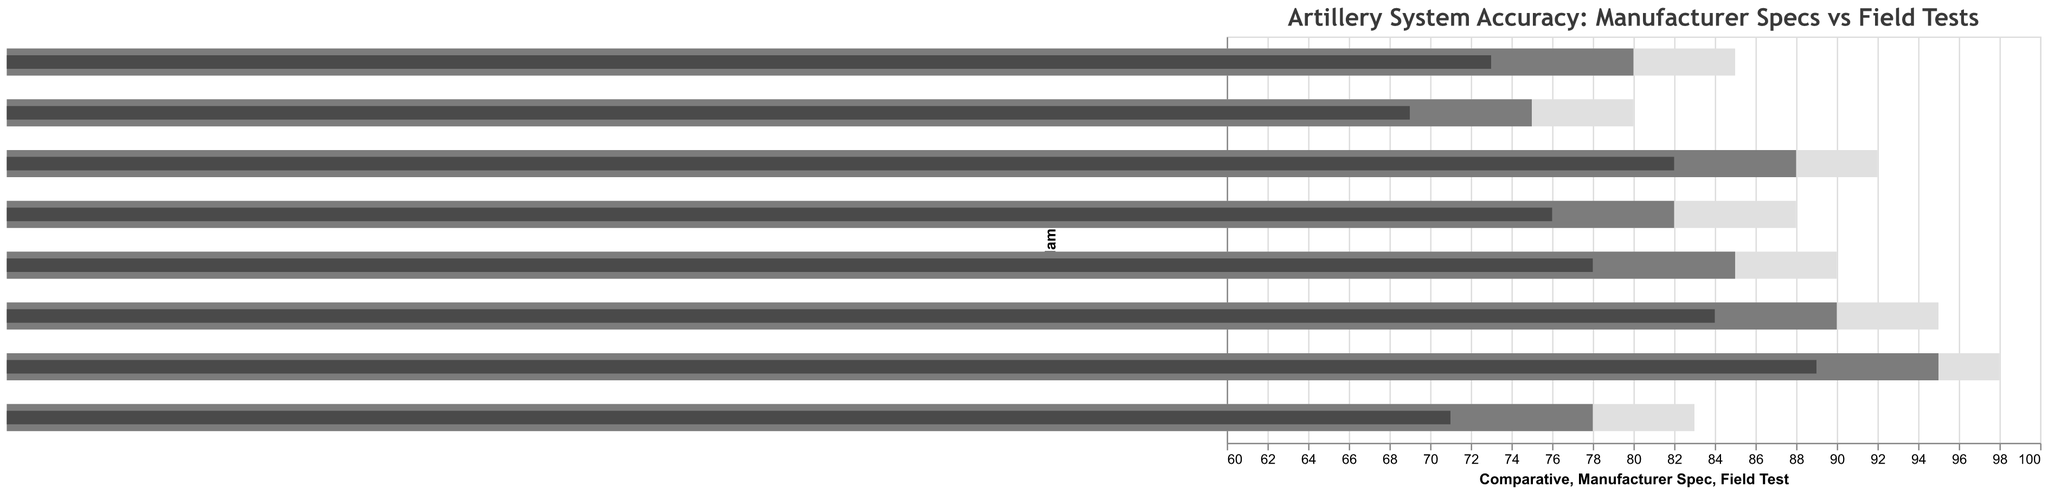Which artillery system has the highest value in the Manufacturer Spec column? Sort the values in the Manufacturer Spec column and identify the highest one. The Panzerhaubitze 2000 has the highest value at 95.
Answer: Panzerhaubitze 2000 How much lower is the Field Test accuracy of the Type 99 155mm compared to its Manufacturer Spec? Subtract the Field Test value from the Manufacturer Spec value for the Type 99 155mm. The difference is 78 - 71 = 7.
Answer: 7 Which artillery system has the closest Field Test accuracy to its Manufacturer Spec? Calculate the differences between each Manufacturer Spec and its corresponding Field Test accuracy. The M777 155mm has a difference of 6, which is the smallest.
Answer: M777 155mm What is the average Field Test accuracy across all artillery systems? Add up all the Field Test accuracies and divide by the number of systems. (78 + 84 + 89 + 73 + 69 + 82 + 76 + 71) / 8 = 622 / 8 = 77.75.
Answer: 77.75 Which artillery system has the lowest Comparative accuracy? Sort the values in the Comparative column and identify the lowest one. The AMX 30 AuF1 has the lowest value at 80.
Answer: AMX 30 AuF1 Among the listed artillery systems, which one shows the highest improvement in Comparative accuracy over Field Test accuracy? Calculate the differences between each Field Test accuracy and Comparative accuracy. The Panzerhaubitze 2000 shows the highest improvement with a difference of 98 - 89 = 9.
Answer: Panzerhaubitze 2000 How many artillery systems have a Field Test accuracy below 80? Count the number of Field Test values below 80. There are five systems: CAESAR 155mm, 2S19 Msta, AMX 30 AuF1, ATMOS 2000, and Type 99 155mm.
Answer: 5 What is the difference between the highest and lowest Manufacturer Spec accuracies? Identify the highest and lowest Manufacturer Spec values and subtract the lowest from the highest. The difference is 95 - 75 = 20.
Answer: 20 Which systems have a Manufacturer Spec accuracy of over 85? Identify values in the Manufacturer Spec column that are greater than 85. The systems are CAESAR 155mm, M777 155mm, Panzerhaubitze 2000, and ARCHER Artillery System.
Answer: CAESAR 155mm, M777 155mm, Panzerhaubitze 2000, ARCHER Artillery System What is the median value of Field Test accuracy across the listed artillery systems? Sort the Field Test values and find the middle number(s). For an even number of values, average the two central numbers. Sorted values are {69, 71, 73, 76, 78, 82, 84, 89}. The median is the average of 76 and 78, which is (76 + 78) / 2 = 77.
Answer: 77 